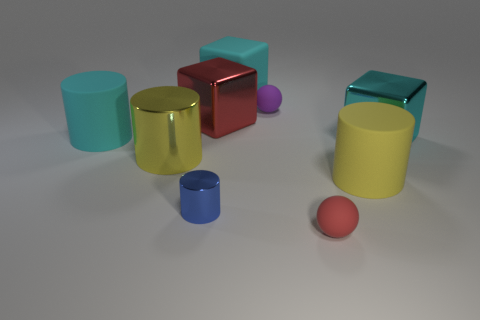Subtract all blue cylinders. How many cylinders are left? 3 Subtract 1 cylinders. How many cylinders are left? 3 Subtract all big yellow metallic cylinders. How many cylinders are left? 3 Subtract all green cylinders. Subtract all red cubes. How many cylinders are left? 4 Subtract all cylinders. How many objects are left? 5 Add 3 blue metal things. How many blue metal things are left? 4 Add 6 cubes. How many cubes exist? 9 Subtract 1 red balls. How many objects are left? 8 Subtract all yellow matte spheres. Subtract all red metal blocks. How many objects are left? 8 